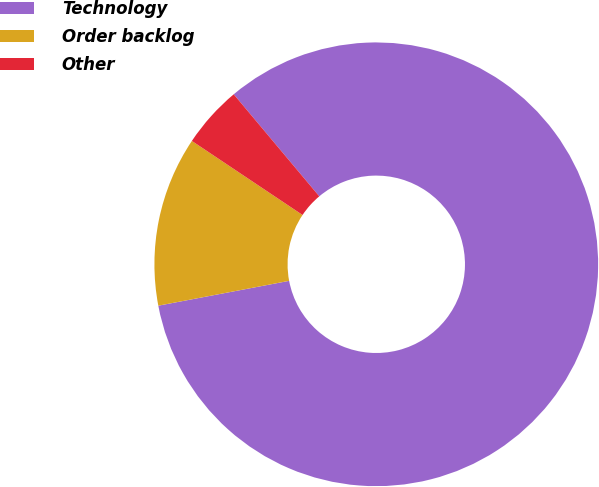Convert chart. <chart><loc_0><loc_0><loc_500><loc_500><pie_chart><fcel>Technology<fcel>Order backlog<fcel>Other<nl><fcel>83.12%<fcel>12.37%<fcel>4.51%<nl></chart> 